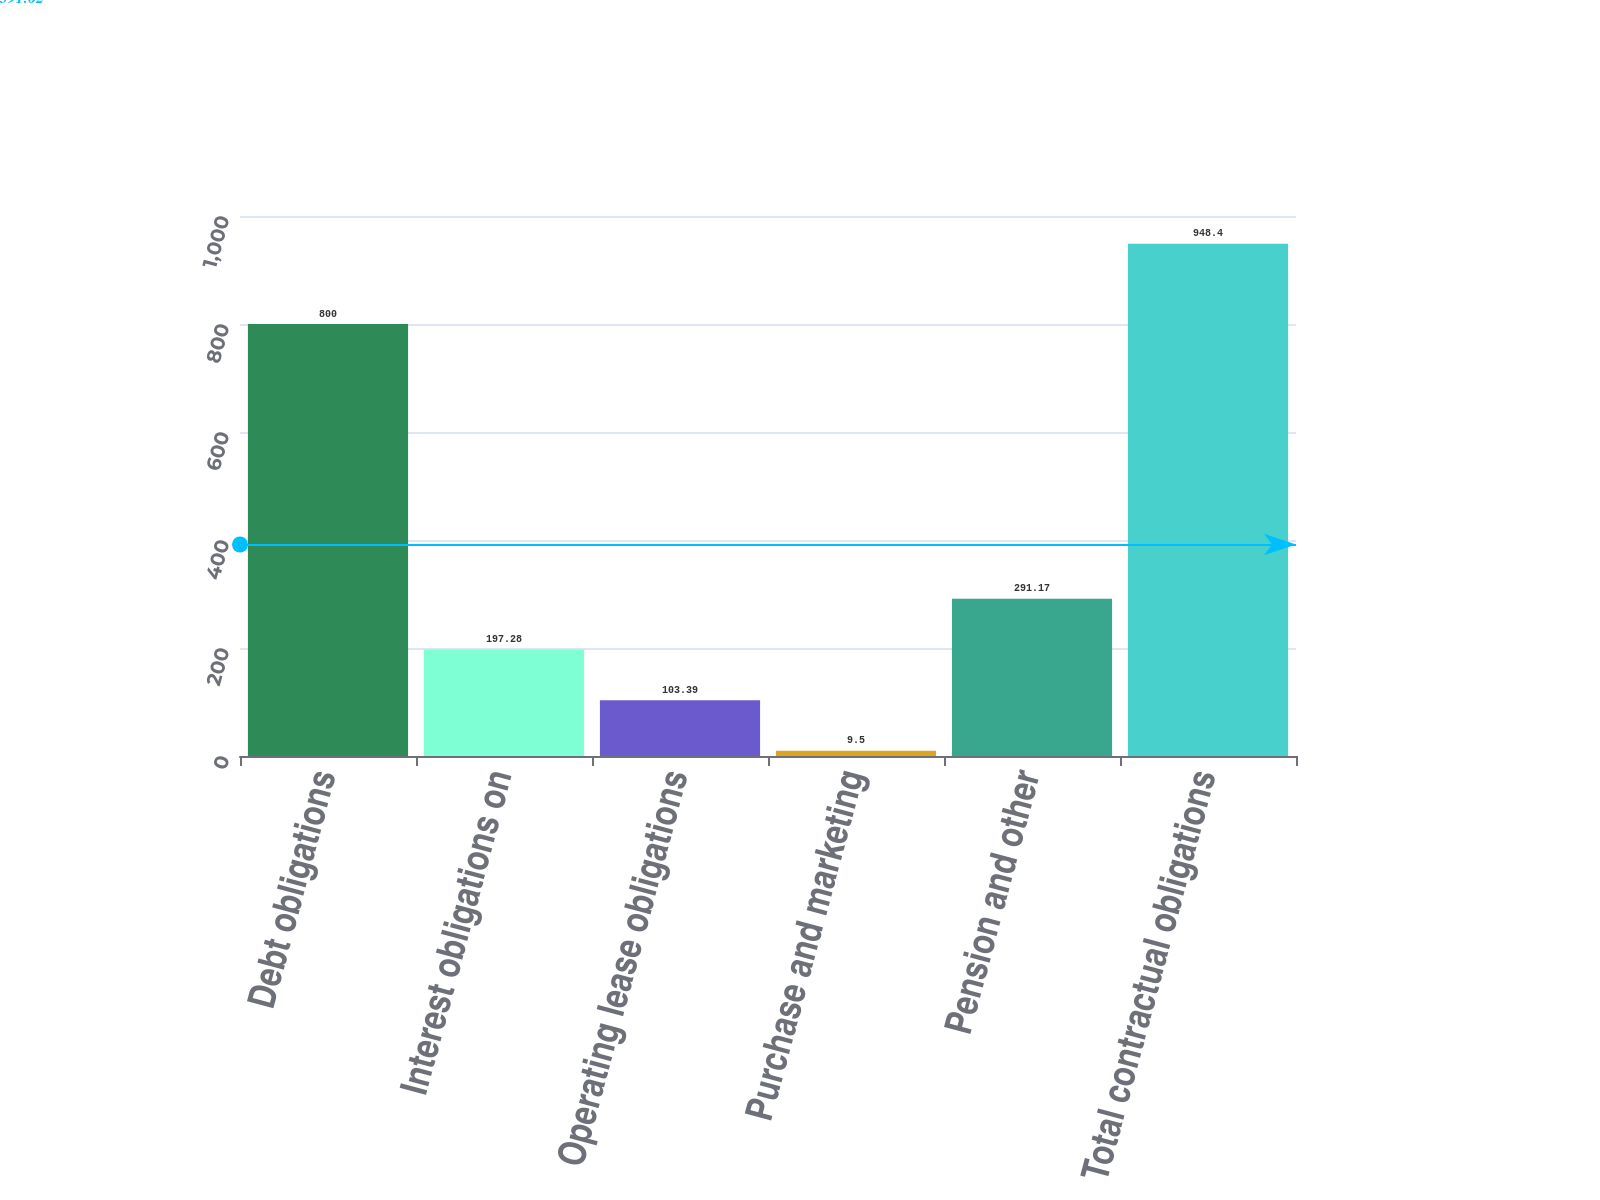Convert chart. <chart><loc_0><loc_0><loc_500><loc_500><bar_chart><fcel>Debt obligations<fcel>Interest obligations on<fcel>Operating lease obligations<fcel>Purchase and marketing<fcel>Pension and other<fcel>Total contractual obligations<nl><fcel>800<fcel>197.28<fcel>103.39<fcel>9.5<fcel>291.17<fcel>948.4<nl></chart> 